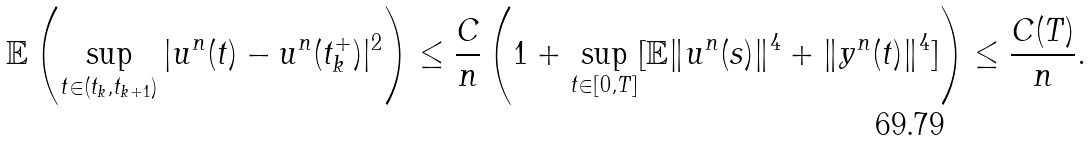<formula> <loc_0><loc_0><loc_500><loc_500>\mathbb { E } \left ( \sup _ { t \in ( t _ { k } , t _ { k + 1 } ) } | u ^ { n } ( t ) - u ^ { n } ( t _ { k } ^ { + } ) | ^ { 2 } \right ) \leq \frac { C } { n } \left ( 1 + \sup _ { t \in [ 0 , T ] } [ \mathbb { E } \| u ^ { n } ( s ) \| ^ { 4 } + \| y ^ { n } ( t ) \| ^ { 4 } ] \right ) \leq \frac { C ( T ) } { n } .</formula> 